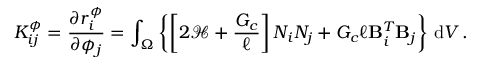<formula> <loc_0><loc_0><loc_500><loc_500>K _ { i j } ^ { \phi } = \frac { \partial r _ { i } ^ { \phi } } { \partial \phi _ { j } } = \int _ { \Omega } \left \{ \left [ 2 \mathcal { H } + \frac { G _ { c } } { \ell } \right ] N _ { i } N _ { j } + G _ { c } \ell B _ { i } ^ { T } B _ { j } \right \} \, d V \, .</formula> 